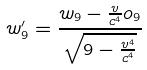Convert formula to latex. <formula><loc_0><loc_0><loc_500><loc_500>w _ { 9 } ^ { \prime } = \frac { w _ { 9 } - \frac { v } { c ^ { 4 } } o _ { 9 } } { \sqrt { 9 - \frac { v ^ { 4 } } { c ^ { 4 } } } }</formula> 